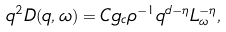Convert formula to latex. <formula><loc_0><loc_0><loc_500><loc_500>q ^ { 2 } D ( q , \omega ) = C g _ { c } \rho ^ { - 1 } q ^ { d - \eta } L _ { \omega } ^ { - \eta } ,</formula> 